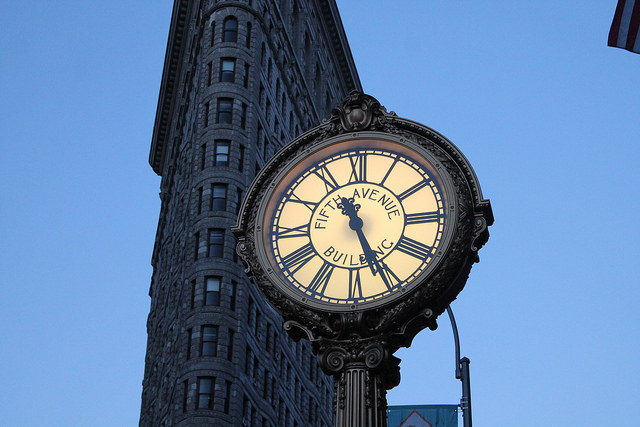Please extract the text content from this image. FIFTH AVENUE BUILDING 